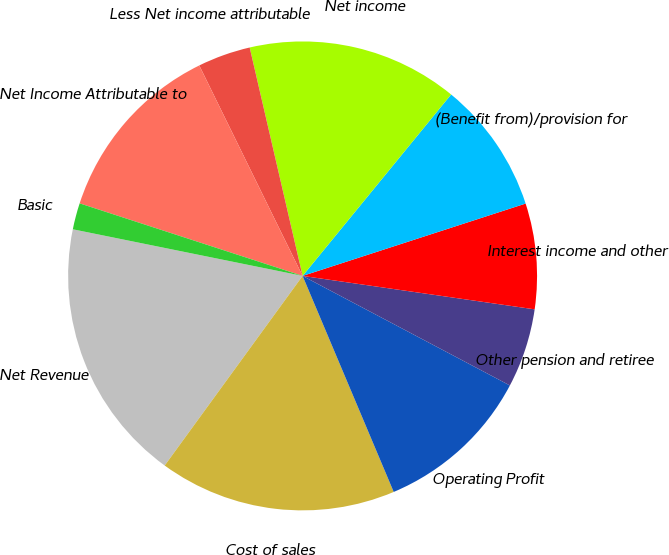<chart> <loc_0><loc_0><loc_500><loc_500><pie_chart><fcel>Net Revenue<fcel>Cost of sales<fcel>Operating Profit<fcel>Other pension and retiree<fcel>Interest income and other<fcel>(Benefit from)/provision for<fcel>Net income<fcel>Less Net income attributable<fcel>Net Income Attributable to<fcel>Basic<nl><fcel>18.18%<fcel>16.36%<fcel>10.91%<fcel>5.46%<fcel>7.27%<fcel>9.09%<fcel>14.54%<fcel>3.64%<fcel>12.73%<fcel>1.82%<nl></chart> 